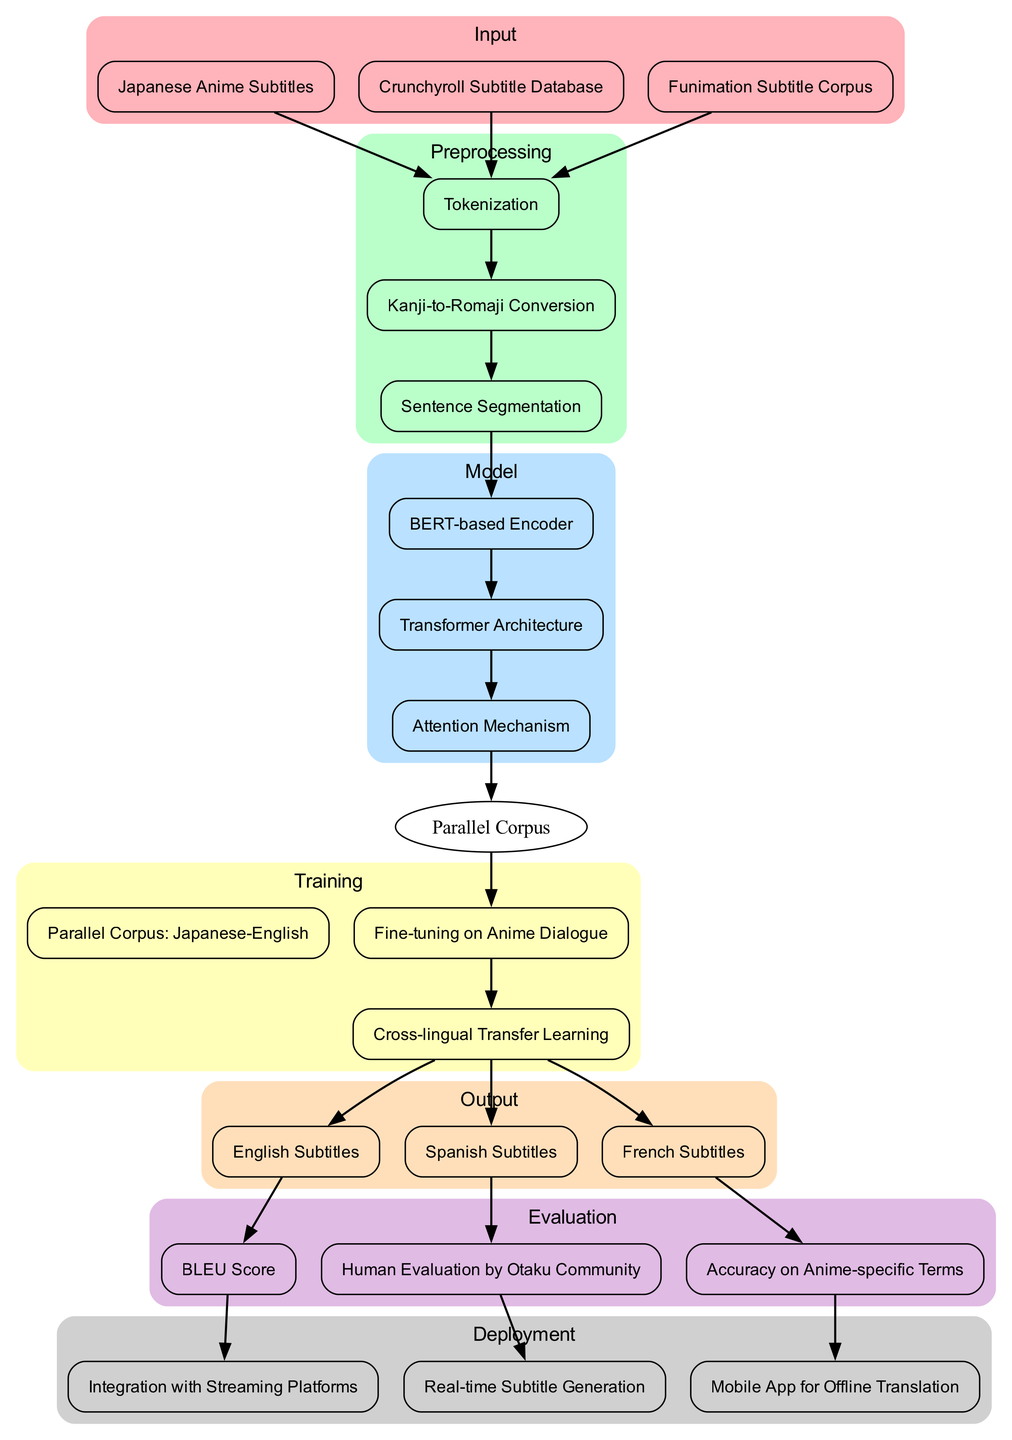What are the three input sources for the model? The diagram lists the inputs as "Japanese Anime Subtitles," "Crunchyroll Subtitle Database," and "Funimation Subtitle Corpus."
Answer: Japanese Anime Subtitles, Crunchyroll Subtitle Database, Funimation Subtitle Corpus How many preprocessing steps are there in total? The diagram specifies three preprocessing steps: Tokenization, Kanji-to-Romaji Conversion, and Sentence Segmentation, leading to a total of three steps.
Answer: 3 What model architecture is used in this process? The diagram identifies "BERT-based Encoder," "Transformer Architecture," and "Attention Mechanism" as the components of the model architecture, indicating that these are all relevant to the translation process.
Answer: BERT-based Encoder, Transformer Architecture, Attention Mechanism What are the three languages for the model's output? The outputs listed in the diagram include "English Subtitles," "Spanish Subtitles," and "French Subtitles."
Answer: English Subtitles, Spanish Subtitles, French Subtitles Which evaluation method involves the otaku community? The diagram specifies "Human Evaluation by Otaku Community" as a method where input from anime fans is utilized to gauge the quality of the translation.
Answer: Human Evaluation by Otaku Community What is the total number of edges leading to the model evaluation phase? The edges connected directly from the outputs "English Subtitles," "Spanish Subtitles," and "French Subtitles," to the evaluation methods indicate a total of three edges leading to this phase.
Answer: 3 Which training step follows the Attention Mechanism? The diagram shows that the next step after the Attention Mechanism is "Parallel Corpus: Japanese-English," as indicated by the directional edge connecting them.
Answer: Parallel Corpus: Japanese-English How does the deployment phase ensure offline access? The diagram indicates that "Mobile App for Offline Translation" is the part of the deployment that provides users the ability to access translations without an internet connection.
Answer: Mobile App for Offline Translation 